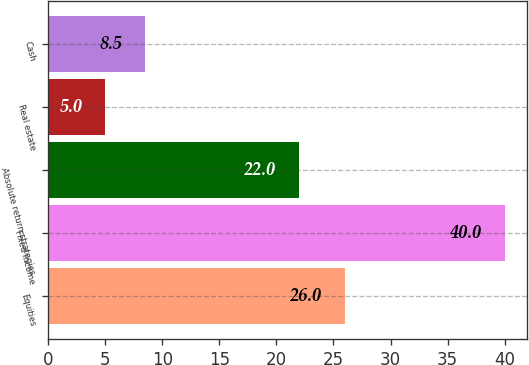Convert chart to OTSL. <chart><loc_0><loc_0><loc_500><loc_500><bar_chart><fcel>Equities<fcel>Fixed income<fcel>Absolute return strategies<fcel>Real estate<fcel>Cash<nl><fcel>26<fcel>40<fcel>22<fcel>5<fcel>8.5<nl></chart> 